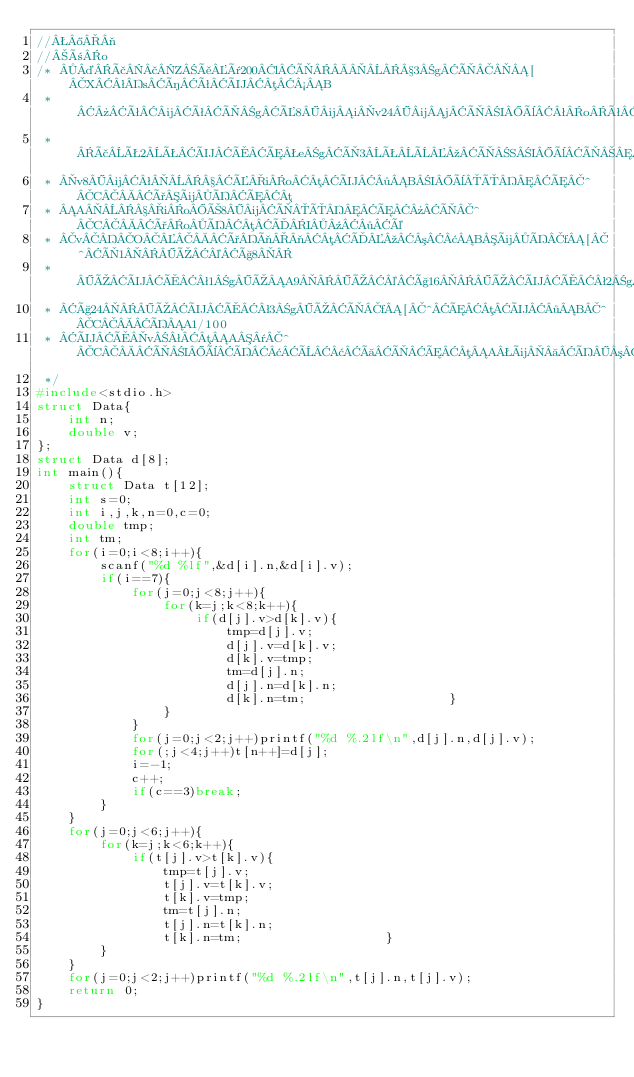<code> <loc_0><loc_0><loc_500><loc_500><_C_>//®¬
//ño
/* ¤ã£Zåï200lÌ3gÌ[XªsíêÜµ½B
 * »ê¼êÌgÉ8¼iv24¼jÌIèªoêµÜ·Beg
 * ãÊ2ÊÜÅÆegÌ3ÊÈºÌSIèÌ©çãÊ2¼Ì
 * v8¼ªÉioµÜ·BIèÔÆ^CðüÍÆµ
 * AioÒ8¼ÌÔÆ»Ì^CðoÍµÄI¹·é
 * vOðì¬µÄº³¢BüÍf[^Ì1Ú©ç8
 * ÚÜÅª1gÚA9Ú©ç16ÚÜÅª2gÚA17Ú©
 * ç24ÚÜÅª3gÚÌf[^ÆµÜ·B^CÍA1/100
 * ÜÅvªµA¯^CÌIèÍ¢È¢àÌÆµAü Í³¢àÌÆµÜ·B
 */
#include<stdio.h>
struct Data{
	int n;
	double v;
};
struct Data d[8];
int main(){
	struct Data t[12];
	int s=0;
	int i,j,k,n=0,c=0;
	double tmp;
	int tm;
	for(i=0;i<8;i++){
		scanf("%d %lf",&d[i].n,&d[i].v);
		if(i==7){
			for(j=0;j<8;j++){
				for(k=j;k<8;k++){
					if(d[j].v>d[k].v){
						tmp=d[j].v;
						d[j].v=d[k].v;
						d[k].v=tmp;
						tm=d[j].n;
						d[j].n=d[k].n;
						d[k].n=tm;					}
				}
			}
			for(j=0;j<2;j++)printf("%d %.2lf\n",d[j].n,d[j].v);
			for(;j<4;j++)t[n++]=d[j];
			i=-1;
			c++;
			if(c==3)break;
		}
	}
	for(j=0;j<6;j++){
		for(k=j;k<6;k++){
			if(t[j].v>t[k].v){
				tmp=t[j].v;
				t[j].v=t[k].v;
				t[k].v=tmp;
				tm=t[j].n;
				t[j].n=t[k].n;
				t[k].n=tm;					}
		}
	}
	for(j=0;j<2;j++)printf("%d %.2lf\n",t[j].n,t[j].v);
	return 0;
}</code> 